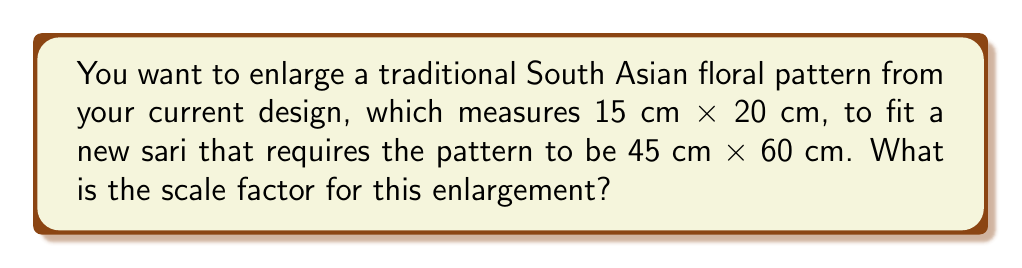Could you help me with this problem? To find the scale factor for enlarging a design, we need to compare the new dimensions to the original dimensions. We can do this by dividing the new size by the original size for either the length or width (both should give the same result).

Let's calculate using both dimensions to verify:

1. Using the width:
   $\text{Scale factor} = \frac{\text{New width}}{\text{Original width}} = \frac{45 \text{ cm}}{15 \text{ cm}} = 3$

2. Using the length:
   $\text{Scale factor} = \frac{\text{New length}}{\text{Original length}} = \frac{60 \text{ cm}}{20 \text{ cm}} = 3$

Both calculations yield the same result, confirming that the scale factor is 3.

This means that each dimension of the original design needs to be multiplied by 3 to achieve the desired size for the new sari pattern.

To verify:
$15 \text{ cm} \times 3 = 45 \text{ cm}$ (new width)
$20 \text{ cm} \times 3 = 60 \text{ cm}$ (new length)

These match the required dimensions for the new sari pattern.
Answer: 3 